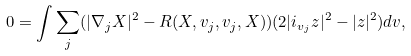Convert formula to latex. <formula><loc_0><loc_0><loc_500><loc_500>0 = \int \sum _ { j } ( | \nabla _ { j } X | ^ { 2 } - R ( X , v _ { j } , v _ { j } , X ) ) ( 2 | i _ { v _ { j } } z | ^ { 2 } - | z | ^ { 2 } ) d v ,</formula> 